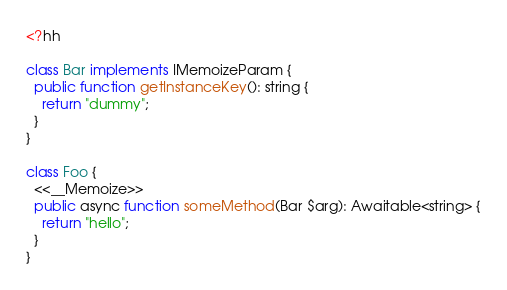<code> <loc_0><loc_0><loc_500><loc_500><_PHP_><?hh

class Bar implements IMemoizeParam {
  public function getInstanceKey(): string {
    return "dummy";
  }
}

class Foo {
  <<__Memoize>>
  public async function someMethod(Bar $arg): Awaitable<string> {
    return "hello";
  }
}
</code> 